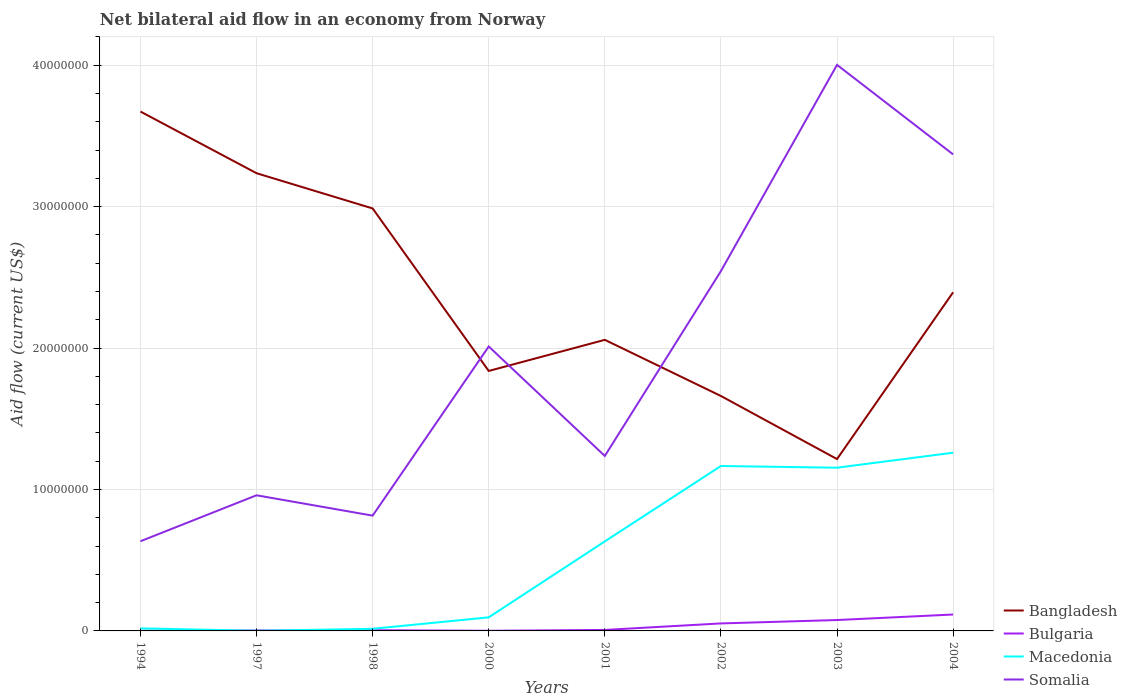Does the line corresponding to Bulgaria intersect with the line corresponding to Macedonia?
Ensure brevity in your answer.  Yes. Across all years, what is the maximum net bilateral aid flow in Bangladesh?
Offer a very short reply. 1.22e+07. What is the total net bilateral aid flow in Bangladesh in the graph?
Keep it short and to the point. 1.33e+07. What is the difference between the highest and the second highest net bilateral aid flow in Macedonia?
Provide a short and direct response. 1.26e+07. What is the difference between the highest and the lowest net bilateral aid flow in Somalia?
Your answer should be very brief. 4. Is the net bilateral aid flow in Bangladesh strictly greater than the net bilateral aid flow in Bulgaria over the years?
Your answer should be very brief. No. How many lines are there?
Offer a very short reply. 4. How many years are there in the graph?
Provide a short and direct response. 8. What is the difference between two consecutive major ticks on the Y-axis?
Provide a succinct answer. 1.00e+07. Where does the legend appear in the graph?
Provide a succinct answer. Bottom right. What is the title of the graph?
Provide a succinct answer. Net bilateral aid flow in an economy from Norway. What is the Aid flow (current US$) of Bangladesh in 1994?
Keep it short and to the point. 3.67e+07. What is the Aid flow (current US$) of Bulgaria in 1994?
Offer a very short reply. 10000. What is the Aid flow (current US$) in Somalia in 1994?
Make the answer very short. 6.34e+06. What is the Aid flow (current US$) in Bangladesh in 1997?
Your answer should be compact. 3.24e+07. What is the Aid flow (current US$) in Bulgaria in 1997?
Your answer should be compact. 3.00e+04. What is the Aid flow (current US$) in Macedonia in 1997?
Offer a terse response. 10000. What is the Aid flow (current US$) in Somalia in 1997?
Provide a short and direct response. 9.59e+06. What is the Aid flow (current US$) of Bangladesh in 1998?
Make the answer very short. 2.99e+07. What is the Aid flow (current US$) in Macedonia in 1998?
Give a very brief answer. 1.50e+05. What is the Aid flow (current US$) in Somalia in 1998?
Provide a short and direct response. 8.15e+06. What is the Aid flow (current US$) of Bangladesh in 2000?
Offer a terse response. 1.84e+07. What is the Aid flow (current US$) in Macedonia in 2000?
Ensure brevity in your answer.  9.60e+05. What is the Aid flow (current US$) of Somalia in 2000?
Your answer should be very brief. 2.01e+07. What is the Aid flow (current US$) in Bangladesh in 2001?
Your response must be concise. 2.06e+07. What is the Aid flow (current US$) of Macedonia in 2001?
Keep it short and to the point. 6.33e+06. What is the Aid flow (current US$) of Somalia in 2001?
Your response must be concise. 1.24e+07. What is the Aid flow (current US$) in Bangladesh in 2002?
Offer a very short reply. 1.66e+07. What is the Aid flow (current US$) of Bulgaria in 2002?
Keep it short and to the point. 5.30e+05. What is the Aid flow (current US$) in Macedonia in 2002?
Provide a succinct answer. 1.17e+07. What is the Aid flow (current US$) in Somalia in 2002?
Your answer should be compact. 2.54e+07. What is the Aid flow (current US$) of Bangladesh in 2003?
Ensure brevity in your answer.  1.22e+07. What is the Aid flow (current US$) in Bulgaria in 2003?
Provide a short and direct response. 7.70e+05. What is the Aid flow (current US$) of Macedonia in 2003?
Offer a very short reply. 1.15e+07. What is the Aid flow (current US$) in Somalia in 2003?
Give a very brief answer. 4.00e+07. What is the Aid flow (current US$) of Bangladesh in 2004?
Your answer should be very brief. 2.39e+07. What is the Aid flow (current US$) in Bulgaria in 2004?
Provide a succinct answer. 1.16e+06. What is the Aid flow (current US$) of Macedonia in 2004?
Your answer should be very brief. 1.26e+07. What is the Aid flow (current US$) in Somalia in 2004?
Provide a succinct answer. 3.37e+07. Across all years, what is the maximum Aid flow (current US$) of Bangladesh?
Give a very brief answer. 3.67e+07. Across all years, what is the maximum Aid flow (current US$) of Bulgaria?
Provide a succinct answer. 1.16e+06. Across all years, what is the maximum Aid flow (current US$) in Macedonia?
Keep it short and to the point. 1.26e+07. Across all years, what is the maximum Aid flow (current US$) in Somalia?
Provide a short and direct response. 4.00e+07. Across all years, what is the minimum Aid flow (current US$) of Bangladesh?
Your answer should be compact. 1.22e+07. Across all years, what is the minimum Aid flow (current US$) in Bulgaria?
Your response must be concise. 10000. Across all years, what is the minimum Aid flow (current US$) in Macedonia?
Provide a short and direct response. 10000. Across all years, what is the minimum Aid flow (current US$) of Somalia?
Keep it short and to the point. 6.34e+06. What is the total Aid flow (current US$) of Bangladesh in the graph?
Give a very brief answer. 1.91e+08. What is the total Aid flow (current US$) in Bulgaria in the graph?
Ensure brevity in your answer.  2.63e+06. What is the total Aid flow (current US$) of Macedonia in the graph?
Offer a terse response. 4.34e+07. What is the total Aid flow (current US$) in Somalia in the graph?
Provide a succinct answer. 1.56e+08. What is the difference between the Aid flow (current US$) in Bangladesh in 1994 and that in 1997?
Provide a succinct answer. 4.36e+06. What is the difference between the Aid flow (current US$) in Macedonia in 1994 and that in 1997?
Make the answer very short. 1.70e+05. What is the difference between the Aid flow (current US$) of Somalia in 1994 and that in 1997?
Ensure brevity in your answer.  -3.25e+06. What is the difference between the Aid flow (current US$) in Bangladesh in 1994 and that in 1998?
Make the answer very short. 6.85e+06. What is the difference between the Aid flow (current US$) of Macedonia in 1994 and that in 1998?
Offer a terse response. 3.00e+04. What is the difference between the Aid flow (current US$) in Somalia in 1994 and that in 1998?
Your response must be concise. -1.81e+06. What is the difference between the Aid flow (current US$) of Bangladesh in 1994 and that in 2000?
Ensure brevity in your answer.  1.83e+07. What is the difference between the Aid flow (current US$) of Macedonia in 1994 and that in 2000?
Give a very brief answer. -7.80e+05. What is the difference between the Aid flow (current US$) in Somalia in 1994 and that in 2000?
Your answer should be compact. -1.38e+07. What is the difference between the Aid flow (current US$) of Bangladesh in 1994 and that in 2001?
Give a very brief answer. 1.61e+07. What is the difference between the Aid flow (current US$) in Macedonia in 1994 and that in 2001?
Give a very brief answer. -6.15e+06. What is the difference between the Aid flow (current US$) of Somalia in 1994 and that in 2001?
Your response must be concise. -6.03e+06. What is the difference between the Aid flow (current US$) of Bangladesh in 1994 and that in 2002?
Keep it short and to the point. 2.01e+07. What is the difference between the Aid flow (current US$) of Bulgaria in 1994 and that in 2002?
Your response must be concise. -5.20e+05. What is the difference between the Aid flow (current US$) in Macedonia in 1994 and that in 2002?
Ensure brevity in your answer.  -1.15e+07. What is the difference between the Aid flow (current US$) of Somalia in 1994 and that in 2002?
Your response must be concise. -1.91e+07. What is the difference between the Aid flow (current US$) of Bangladesh in 1994 and that in 2003?
Your answer should be compact. 2.46e+07. What is the difference between the Aid flow (current US$) of Bulgaria in 1994 and that in 2003?
Give a very brief answer. -7.60e+05. What is the difference between the Aid flow (current US$) of Macedonia in 1994 and that in 2003?
Your answer should be very brief. -1.14e+07. What is the difference between the Aid flow (current US$) of Somalia in 1994 and that in 2003?
Provide a short and direct response. -3.37e+07. What is the difference between the Aid flow (current US$) in Bangladesh in 1994 and that in 2004?
Keep it short and to the point. 1.28e+07. What is the difference between the Aid flow (current US$) in Bulgaria in 1994 and that in 2004?
Offer a terse response. -1.15e+06. What is the difference between the Aid flow (current US$) in Macedonia in 1994 and that in 2004?
Ensure brevity in your answer.  -1.24e+07. What is the difference between the Aid flow (current US$) of Somalia in 1994 and that in 2004?
Your answer should be very brief. -2.74e+07. What is the difference between the Aid flow (current US$) in Bangladesh in 1997 and that in 1998?
Provide a short and direct response. 2.49e+06. What is the difference between the Aid flow (current US$) of Somalia in 1997 and that in 1998?
Your answer should be very brief. 1.44e+06. What is the difference between the Aid flow (current US$) in Bangladesh in 1997 and that in 2000?
Give a very brief answer. 1.40e+07. What is the difference between the Aid flow (current US$) of Bulgaria in 1997 and that in 2000?
Provide a succinct answer. 2.00e+04. What is the difference between the Aid flow (current US$) of Macedonia in 1997 and that in 2000?
Provide a succinct answer. -9.50e+05. What is the difference between the Aid flow (current US$) in Somalia in 1997 and that in 2000?
Give a very brief answer. -1.05e+07. What is the difference between the Aid flow (current US$) in Bangladesh in 1997 and that in 2001?
Keep it short and to the point. 1.18e+07. What is the difference between the Aid flow (current US$) of Macedonia in 1997 and that in 2001?
Make the answer very short. -6.32e+06. What is the difference between the Aid flow (current US$) in Somalia in 1997 and that in 2001?
Provide a short and direct response. -2.78e+06. What is the difference between the Aid flow (current US$) of Bangladesh in 1997 and that in 2002?
Provide a succinct answer. 1.58e+07. What is the difference between the Aid flow (current US$) of Bulgaria in 1997 and that in 2002?
Your answer should be compact. -5.00e+05. What is the difference between the Aid flow (current US$) in Macedonia in 1997 and that in 2002?
Offer a very short reply. -1.16e+07. What is the difference between the Aid flow (current US$) of Somalia in 1997 and that in 2002?
Give a very brief answer. -1.58e+07. What is the difference between the Aid flow (current US$) in Bangladesh in 1997 and that in 2003?
Offer a very short reply. 2.02e+07. What is the difference between the Aid flow (current US$) of Bulgaria in 1997 and that in 2003?
Offer a terse response. -7.40e+05. What is the difference between the Aid flow (current US$) of Macedonia in 1997 and that in 2003?
Make the answer very short. -1.15e+07. What is the difference between the Aid flow (current US$) in Somalia in 1997 and that in 2003?
Your answer should be very brief. -3.04e+07. What is the difference between the Aid flow (current US$) in Bangladesh in 1997 and that in 2004?
Offer a very short reply. 8.42e+06. What is the difference between the Aid flow (current US$) of Bulgaria in 1997 and that in 2004?
Your response must be concise. -1.13e+06. What is the difference between the Aid flow (current US$) of Macedonia in 1997 and that in 2004?
Offer a very short reply. -1.26e+07. What is the difference between the Aid flow (current US$) in Somalia in 1997 and that in 2004?
Make the answer very short. -2.41e+07. What is the difference between the Aid flow (current US$) in Bangladesh in 1998 and that in 2000?
Your response must be concise. 1.15e+07. What is the difference between the Aid flow (current US$) in Bulgaria in 1998 and that in 2000?
Your answer should be very brief. 4.00e+04. What is the difference between the Aid flow (current US$) in Macedonia in 1998 and that in 2000?
Ensure brevity in your answer.  -8.10e+05. What is the difference between the Aid flow (current US$) of Somalia in 1998 and that in 2000?
Provide a succinct answer. -1.20e+07. What is the difference between the Aid flow (current US$) in Bangladesh in 1998 and that in 2001?
Offer a terse response. 9.29e+06. What is the difference between the Aid flow (current US$) of Macedonia in 1998 and that in 2001?
Provide a succinct answer. -6.18e+06. What is the difference between the Aid flow (current US$) in Somalia in 1998 and that in 2001?
Give a very brief answer. -4.22e+06. What is the difference between the Aid flow (current US$) of Bangladesh in 1998 and that in 2002?
Your answer should be very brief. 1.33e+07. What is the difference between the Aid flow (current US$) of Bulgaria in 1998 and that in 2002?
Your answer should be compact. -4.80e+05. What is the difference between the Aid flow (current US$) in Macedonia in 1998 and that in 2002?
Make the answer very short. -1.15e+07. What is the difference between the Aid flow (current US$) of Somalia in 1998 and that in 2002?
Offer a very short reply. -1.73e+07. What is the difference between the Aid flow (current US$) of Bangladesh in 1998 and that in 2003?
Provide a short and direct response. 1.77e+07. What is the difference between the Aid flow (current US$) of Bulgaria in 1998 and that in 2003?
Ensure brevity in your answer.  -7.20e+05. What is the difference between the Aid flow (current US$) of Macedonia in 1998 and that in 2003?
Keep it short and to the point. -1.14e+07. What is the difference between the Aid flow (current US$) in Somalia in 1998 and that in 2003?
Offer a terse response. -3.19e+07. What is the difference between the Aid flow (current US$) of Bangladesh in 1998 and that in 2004?
Offer a very short reply. 5.93e+06. What is the difference between the Aid flow (current US$) in Bulgaria in 1998 and that in 2004?
Your answer should be very brief. -1.11e+06. What is the difference between the Aid flow (current US$) in Macedonia in 1998 and that in 2004?
Keep it short and to the point. -1.24e+07. What is the difference between the Aid flow (current US$) of Somalia in 1998 and that in 2004?
Make the answer very short. -2.55e+07. What is the difference between the Aid flow (current US$) in Bangladesh in 2000 and that in 2001?
Your answer should be very brief. -2.20e+06. What is the difference between the Aid flow (current US$) in Macedonia in 2000 and that in 2001?
Keep it short and to the point. -5.37e+06. What is the difference between the Aid flow (current US$) of Somalia in 2000 and that in 2001?
Keep it short and to the point. 7.74e+06. What is the difference between the Aid flow (current US$) in Bangladesh in 2000 and that in 2002?
Ensure brevity in your answer.  1.77e+06. What is the difference between the Aid flow (current US$) in Bulgaria in 2000 and that in 2002?
Provide a succinct answer. -5.20e+05. What is the difference between the Aid flow (current US$) of Macedonia in 2000 and that in 2002?
Ensure brevity in your answer.  -1.07e+07. What is the difference between the Aid flow (current US$) in Somalia in 2000 and that in 2002?
Ensure brevity in your answer.  -5.33e+06. What is the difference between the Aid flow (current US$) in Bangladesh in 2000 and that in 2003?
Offer a terse response. 6.23e+06. What is the difference between the Aid flow (current US$) of Bulgaria in 2000 and that in 2003?
Your response must be concise. -7.60e+05. What is the difference between the Aid flow (current US$) in Macedonia in 2000 and that in 2003?
Your answer should be very brief. -1.06e+07. What is the difference between the Aid flow (current US$) in Somalia in 2000 and that in 2003?
Your answer should be very brief. -1.99e+07. What is the difference between the Aid flow (current US$) in Bangladesh in 2000 and that in 2004?
Offer a terse response. -5.56e+06. What is the difference between the Aid flow (current US$) in Bulgaria in 2000 and that in 2004?
Make the answer very short. -1.15e+06. What is the difference between the Aid flow (current US$) in Macedonia in 2000 and that in 2004?
Offer a terse response. -1.16e+07. What is the difference between the Aid flow (current US$) of Somalia in 2000 and that in 2004?
Offer a terse response. -1.36e+07. What is the difference between the Aid flow (current US$) of Bangladesh in 2001 and that in 2002?
Offer a very short reply. 3.97e+06. What is the difference between the Aid flow (current US$) in Bulgaria in 2001 and that in 2002?
Your answer should be compact. -4.60e+05. What is the difference between the Aid flow (current US$) in Macedonia in 2001 and that in 2002?
Your response must be concise. -5.33e+06. What is the difference between the Aid flow (current US$) of Somalia in 2001 and that in 2002?
Make the answer very short. -1.31e+07. What is the difference between the Aid flow (current US$) in Bangladesh in 2001 and that in 2003?
Offer a terse response. 8.43e+06. What is the difference between the Aid flow (current US$) of Bulgaria in 2001 and that in 2003?
Offer a very short reply. -7.00e+05. What is the difference between the Aid flow (current US$) in Macedonia in 2001 and that in 2003?
Keep it short and to the point. -5.21e+06. What is the difference between the Aid flow (current US$) in Somalia in 2001 and that in 2003?
Give a very brief answer. -2.76e+07. What is the difference between the Aid flow (current US$) in Bangladesh in 2001 and that in 2004?
Offer a terse response. -3.36e+06. What is the difference between the Aid flow (current US$) in Bulgaria in 2001 and that in 2004?
Provide a short and direct response. -1.09e+06. What is the difference between the Aid flow (current US$) of Macedonia in 2001 and that in 2004?
Provide a succinct answer. -6.27e+06. What is the difference between the Aid flow (current US$) of Somalia in 2001 and that in 2004?
Keep it short and to the point. -2.13e+07. What is the difference between the Aid flow (current US$) of Bangladesh in 2002 and that in 2003?
Offer a terse response. 4.46e+06. What is the difference between the Aid flow (current US$) of Bulgaria in 2002 and that in 2003?
Give a very brief answer. -2.40e+05. What is the difference between the Aid flow (current US$) in Macedonia in 2002 and that in 2003?
Offer a terse response. 1.20e+05. What is the difference between the Aid flow (current US$) of Somalia in 2002 and that in 2003?
Provide a short and direct response. -1.46e+07. What is the difference between the Aid flow (current US$) in Bangladesh in 2002 and that in 2004?
Offer a very short reply. -7.33e+06. What is the difference between the Aid flow (current US$) in Bulgaria in 2002 and that in 2004?
Your answer should be compact. -6.30e+05. What is the difference between the Aid flow (current US$) of Macedonia in 2002 and that in 2004?
Give a very brief answer. -9.40e+05. What is the difference between the Aid flow (current US$) in Somalia in 2002 and that in 2004?
Keep it short and to the point. -8.25e+06. What is the difference between the Aid flow (current US$) of Bangladesh in 2003 and that in 2004?
Keep it short and to the point. -1.18e+07. What is the difference between the Aid flow (current US$) of Bulgaria in 2003 and that in 2004?
Provide a short and direct response. -3.90e+05. What is the difference between the Aid flow (current US$) in Macedonia in 2003 and that in 2004?
Provide a short and direct response. -1.06e+06. What is the difference between the Aid flow (current US$) of Somalia in 2003 and that in 2004?
Provide a short and direct response. 6.33e+06. What is the difference between the Aid flow (current US$) of Bangladesh in 1994 and the Aid flow (current US$) of Bulgaria in 1997?
Your response must be concise. 3.67e+07. What is the difference between the Aid flow (current US$) in Bangladesh in 1994 and the Aid flow (current US$) in Macedonia in 1997?
Give a very brief answer. 3.67e+07. What is the difference between the Aid flow (current US$) of Bangladesh in 1994 and the Aid flow (current US$) of Somalia in 1997?
Make the answer very short. 2.71e+07. What is the difference between the Aid flow (current US$) of Bulgaria in 1994 and the Aid flow (current US$) of Macedonia in 1997?
Provide a succinct answer. 0. What is the difference between the Aid flow (current US$) in Bulgaria in 1994 and the Aid flow (current US$) in Somalia in 1997?
Ensure brevity in your answer.  -9.58e+06. What is the difference between the Aid flow (current US$) in Macedonia in 1994 and the Aid flow (current US$) in Somalia in 1997?
Offer a very short reply. -9.41e+06. What is the difference between the Aid flow (current US$) in Bangladesh in 1994 and the Aid flow (current US$) in Bulgaria in 1998?
Your answer should be compact. 3.67e+07. What is the difference between the Aid flow (current US$) in Bangladesh in 1994 and the Aid flow (current US$) in Macedonia in 1998?
Your answer should be very brief. 3.66e+07. What is the difference between the Aid flow (current US$) in Bangladesh in 1994 and the Aid flow (current US$) in Somalia in 1998?
Keep it short and to the point. 2.86e+07. What is the difference between the Aid flow (current US$) in Bulgaria in 1994 and the Aid flow (current US$) in Macedonia in 1998?
Your answer should be compact. -1.40e+05. What is the difference between the Aid flow (current US$) in Bulgaria in 1994 and the Aid flow (current US$) in Somalia in 1998?
Provide a short and direct response. -8.14e+06. What is the difference between the Aid flow (current US$) in Macedonia in 1994 and the Aid flow (current US$) in Somalia in 1998?
Ensure brevity in your answer.  -7.97e+06. What is the difference between the Aid flow (current US$) of Bangladesh in 1994 and the Aid flow (current US$) of Bulgaria in 2000?
Ensure brevity in your answer.  3.67e+07. What is the difference between the Aid flow (current US$) of Bangladesh in 1994 and the Aid flow (current US$) of Macedonia in 2000?
Offer a very short reply. 3.58e+07. What is the difference between the Aid flow (current US$) of Bangladesh in 1994 and the Aid flow (current US$) of Somalia in 2000?
Ensure brevity in your answer.  1.66e+07. What is the difference between the Aid flow (current US$) in Bulgaria in 1994 and the Aid flow (current US$) in Macedonia in 2000?
Provide a succinct answer. -9.50e+05. What is the difference between the Aid flow (current US$) in Bulgaria in 1994 and the Aid flow (current US$) in Somalia in 2000?
Offer a very short reply. -2.01e+07. What is the difference between the Aid flow (current US$) of Macedonia in 1994 and the Aid flow (current US$) of Somalia in 2000?
Provide a succinct answer. -1.99e+07. What is the difference between the Aid flow (current US$) in Bangladesh in 1994 and the Aid flow (current US$) in Bulgaria in 2001?
Your answer should be very brief. 3.66e+07. What is the difference between the Aid flow (current US$) of Bangladesh in 1994 and the Aid flow (current US$) of Macedonia in 2001?
Your response must be concise. 3.04e+07. What is the difference between the Aid flow (current US$) of Bangladesh in 1994 and the Aid flow (current US$) of Somalia in 2001?
Ensure brevity in your answer.  2.44e+07. What is the difference between the Aid flow (current US$) of Bulgaria in 1994 and the Aid flow (current US$) of Macedonia in 2001?
Provide a short and direct response. -6.32e+06. What is the difference between the Aid flow (current US$) in Bulgaria in 1994 and the Aid flow (current US$) in Somalia in 2001?
Provide a short and direct response. -1.24e+07. What is the difference between the Aid flow (current US$) in Macedonia in 1994 and the Aid flow (current US$) in Somalia in 2001?
Provide a short and direct response. -1.22e+07. What is the difference between the Aid flow (current US$) of Bangladesh in 1994 and the Aid flow (current US$) of Bulgaria in 2002?
Give a very brief answer. 3.62e+07. What is the difference between the Aid flow (current US$) in Bangladesh in 1994 and the Aid flow (current US$) in Macedonia in 2002?
Ensure brevity in your answer.  2.51e+07. What is the difference between the Aid flow (current US$) in Bangladesh in 1994 and the Aid flow (current US$) in Somalia in 2002?
Your answer should be compact. 1.13e+07. What is the difference between the Aid flow (current US$) of Bulgaria in 1994 and the Aid flow (current US$) of Macedonia in 2002?
Provide a succinct answer. -1.16e+07. What is the difference between the Aid flow (current US$) of Bulgaria in 1994 and the Aid flow (current US$) of Somalia in 2002?
Give a very brief answer. -2.54e+07. What is the difference between the Aid flow (current US$) of Macedonia in 1994 and the Aid flow (current US$) of Somalia in 2002?
Offer a very short reply. -2.53e+07. What is the difference between the Aid flow (current US$) in Bangladesh in 1994 and the Aid flow (current US$) in Bulgaria in 2003?
Your answer should be very brief. 3.60e+07. What is the difference between the Aid flow (current US$) in Bangladesh in 1994 and the Aid flow (current US$) in Macedonia in 2003?
Make the answer very short. 2.52e+07. What is the difference between the Aid flow (current US$) of Bangladesh in 1994 and the Aid flow (current US$) of Somalia in 2003?
Your response must be concise. -3.30e+06. What is the difference between the Aid flow (current US$) in Bulgaria in 1994 and the Aid flow (current US$) in Macedonia in 2003?
Give a very brief answer. -1.15e+07. What is the difference between the Aid flow (current US$) of Bulgaria in 1994 and the Aid flow (current US$) of Somalia in 2003?
Ensure brevity in your answer.  -4.00e+07. What is the difference between the Aid flow (current US$) in Macedonia in 1994 and the Aid flow (current US$) in Somalia in 2003?
Your answer should be very brief. -3.98e+07. What is the difference between the Aid flow (current US$) in Bangladesh in 1994 and the Aid flow (current US$) in Bulgaria in 2004?
Offer a very short reply. 3.56e+07. What is the difference between the Aid flow (current US$) in Bangladesh in 1994 and the Aid flow (current US$) in Macedonia in 2004?
Offer a very short reply. 2.41e+07. What is the difference between the Aid flow (current US$) of Bangladesh in 1994 and the Aid flow (current US$) of Somalia in 2004?
Your answer should be very brief. 3.03e+06. What is the difference between the Aid flow (current US$) of Bulgaria in 1994 and the Aid flow (current US$) of Macedonia in 2004?
Provide a short and direct response. -1.26e+07. What is the difference between the Aid flow (current US$) in Bulgaria in 1994 and the Aid flow (current US$) in Somalia in 2004?
Make the answer very short. -3.37e+07. What is the difference between the Aid flow (current US$) in Macedonia in 1994 and the Aid flow (current US$) in Somalia in 2004?
Your response must be concise. -3.35e+07. What is the difference between the Aid flow (current US$) in Bangladesh in 1997 and the Aid flow (current US$) in Bulgaria in 1998?
Your response must be concise. 3.23e+07. What is the difference between the Aid flow (current US$) in Bangladesh in 1997 and the Aid flow (current US$) in Macedonia in 1998?
Make the answer very short. 3.22e+07. What is the difference between the Aid flow (current US$) in Bangladesh in 1997 and the Aid flow (current US$) in Somalia in 1998?
Give a very brief answer. 2.42e+07. What is the difference between the Aid flow (current US$) in Bulgaria in 1997 and the Aid flow (current US$) in Somalia in 1998?
Keep it short and to the point. -8.12e+06. What is the difference between the Aid flow (current US$) of Macedonia in 1997 and the Aid flow (current US$) of Somalia in 1998?
Keep it short and to the point. -8.14e+06. What is the difference between the Aid flow (current US$) in Bangladesh in 1997 and the Aid flow (current US$) in Bulgaria in 2000?
Your answer should be compact. 3.24e+07. What is the difference between the Aid flow (current US$) in Bangladesh in 1997 and the Aid flow (current US$) in Macedonia in 2000?
Provide a short and direct response. 3.14e+07. What is the difference between the Aid flow (current US$) in Bangladesh in 1997 and the Aid flow (current US$) in Somalia in 2000?
Make the answer very short. 1.22e+07. What is the difference between the Aid flow (current US$) in Bulgaria in 1997 and the Aid flow (current US$) in Macedonia in 2000?
Your answer should be compact. -9.30e+05. What is the difference between the Aid flow (current US$) in Bulgaria in 1997 and the Aid flow (current US$) in Somalia in 2000?
Your response must be concise. -2.01e+07. What is the difference between the Aid flow (current US$) of Macedonia in 1997 and the Aid flow (current US$) of Somalia in 2000?
Keep it short and to the point. -2.01e+07. What is the difference between the Aid flow (current US$) of Bangladesh in 1997 and the Aid flow (current US$) of Bulgaria in 2001?
Your answer should be compact. 3.23e+07. What is the difference between the Aid flow (current US$) in Bangladesh in 1997 and the Aid flow (current US$) in Macedonia in 2001?
Provide a short and direct response. 2.60e+07. What is the difference between the Aid flow (current US$) in Bangladesh in 1997 and the Aid flow (current US$) in Somalia in 2001?
Offer a very short reply. 2.00e+07. What is the difference between the Aid flow (current US$) in Bulgaria in 1997 and the Aid flow (current US$) in Macedonia in 2001?
Keep it short and to the point. -6.30e+06. What is the difference between the Aid flow (current US$) in Bulgaria in 1997 and the Aid flow (current US$) in Somalia in 2001?
Your answer should be compact. -1.23e+07. What is the difference between the Aid flow (current US$) in Macedonia in 1997 and the Aid flow (current US$) in Somalia in 2001?
Keep it short and to the point. -1.24e+07. What is the difference between the Aid flow (current US$) in Bangladesh in 1997 and the Aid flow (current US$) in Bulgaria in 2002?
Provide a succinct answer. 3.18e+07. What is the difference between the Aid flow (current US$) of Bangladesh in 1997 and the Aid flow (current US$) of Macedonia in 2002?
Keep it short and to the point. 2.07e+07. What is the difference between the Aid flow (current US$) of Bangladesh in 1997 and the Aid flow (current US$) of Somalia in 2002?
Your answer should be very brief. 6.92e+06. What is the difference between the Aid flow (current US$) in Bulgaria in 1997 and the Aid flow (current US$) in Macedonia in 2002?
Make the answer very short. -1.16e+07. What is the difference between the Aid flow (current US$) in Bulgaria in 1997 and the Aid flow (current US$) in Somalia in 2002?
Provide a short and direct response. -2.54e+07. What is the difference between the Aid flow (current US$) of Macedonia in 1997 and the Aid flow (current US$) of Somalia in 2002?
Provide a short and direct response. -2.54e+07. What is the difference between the Aid flow (current US$) of Bangladesh in 1997 and the Aid flow (current US$) of Bulgaria in 2003?
Provide a succinct answer. 3.16e+07. What is the difference between the Aid flow (current US$) of Bangladesh in 1997 and the Aid flow (current US$) of Macedonia in 2003?
Your answer should be very brief. 2.08e+07. What is the difference between the Aid flow (current US$) in Bangladesh in 1997 and the Aid flow (current US$) in Somalia in 2003?
Provide a short and direct response. -7.66e+06. What is the difference between the Aid flow (current US$) of Bulgaria in 1997 and the Aid flow (current US$) of Macedonia in 2003?
Your answer should be compact. -1.15e+07. What is the difference between the Aid flow (current US$) in Bulgaria in 1997 and the Aid flow (current US$) in Somalia in 2003?
Keep it short and to the point. -4.00e+07. What is the difference between the Aid flow (current US$) in Macedonia in 1997 and the Aid flow (current US$) in Somalia in 2003?
Provide a short and direct response. -4.00e+07. What is the difference between the Aid flow (current US$) in Bangladesh in 1997 and the Aid flow (current US$) in Bulgaria in 2004?
Offer a terse response. 3.12e+07. What is the difference between the Aid flow (current US$) of Bangladesh in 1997 and the Aid flow (current US$) of Macedonia in 2004?
Keep it short and to the point. 1.98e+07. What is the difference between the Aid flow (current US$) in Bangladesh in 1997 and the Aid flow (current US$) in Somalia in 2004?
Your response must be concise. -1.33e+06. What is the difference between the Aid flow (current US$) in Bulgaria in 1997 and the Aid flow (current US$) in Macedonia in 2004?
Ensure brevity in your answer.  -1.26e+07. What is the difference between the Aid flow (current US$) of Bulgaria in 1997 and the Aid flow (current US$) of Somalia in 2004?
Keep it short and to the point. -3.37e+07. What is the difference between the Aid flow (current US$) in Macedonia in 1997 and the Aid flow (current US$) in Somalia in 2004?
Provide a succinct answer. -3.37e+07. What is the difference between the Aid flow (current US$) in Bangladesh in 1998 and the Aid flow (current US$) in Bulgaria in 2000?
Make the answer very short. 2.99e+07. What is the difference between the Aid flow (current US$) in Bangladesh in 1998 and the Aid flow (current US$) in Macedonia in 2000?
Keep it short and to the point. 2.89e+07. What is the difference between the Aid flow (current US$) in Bangladesh in 1998 and the Aid flow (current US$) in Somalia in 2000?
Keep it short and to the point. 9.76e+06. What is the difference between the Aid flow (current US$) in Bulgaria in 1998 and the Aid flow (current US$) in Macedonia in 2000?
Make the answer very short. -9.10e+05. What is the difference between the Aid flow (current US$) of Bulgaria in 1998 and the Aid flow (current US$) of Somalia in 2000?
Your answer should be very brief. -2.01e+07. What is the difference between the Aid flow (current US$) in Macedonia in 1998 and the Aid flow (current US$) in Somalia in 2000?
Offer a terse response. -2.00e+07. What is the difference between the Aid flow (current US$) of Bangladesh in 1998 and the Aid flow (current US$) of Bulgaria in 2001?
Make the answer very short. 2.98e+07. What is the difference between the Aid flow (current US$) in Bangladesh in 1998 and the Aid flow (current US$) in Macedonia in 2001?
Your answer should be compact. 2.35e+07. What is the difference between the Aid flow (current US$) of Bangladesh in 1998 and the Aid flow (current US$) of Somalia in 2001?
Your answer should be compact. 1.75e+07. What is the difference between the Aid flow (current US$) of Bulgaria in 1998 and the Aid flow (current US$) of Macedonia in 2001?
Ensure brevity in your answer.  -6.28e+06. What is the difference between the Aid flow (current US$) of Bulgaria in 1998 and the Aid flow (current US$) of Somalia in 2001?
Offer a terse response. -1.23e+07. What is the difference between the Aid flow (current US$) of Macedonia in 1998 and the Aid flow (current US$) of Somalia in 2001?
Provide a succinct answer. -1.22e+07. What is the difference between the Aid flow (current US$) of Bangladesh in 1998 and the Aid flow (current US$) of Bulgaria in 2002?
Provide a succinct answer. 2.93e+07. What is the difference between the Aid flow (current US$) of Bangladesh in 1998 and the Aid flow (current US$) of Macedonia in 2002?
Your response must be concise. 1.82e+07. What is the difference between the Aid flow (current US$) in Bangladesh in 1998 and the Aid flow (current US$) in Somalia in 2002?
Your answer should be compact. 4.43e+06. What is the difference between the Aid flow (current US$) of Bulgaria in 1998 and the Aid flow (current US$) of Macedonia in 2002?
Your answer should be very brief. -1.16e+07. What is the difference between the Aid flow (current US$) in Bulgaria in 1998 and the Aid flow (current US$) in Somalia in 2002?
Provide a short and direct response. -2.54e+07. What is the difference between the Aid flow (current US$) of Macedonia in 1998 and the Aid flow (current US$) of Somalia in 2002?
Offer a terse response. -2.53e+07. What is the difference between the Aid flow (current US$) of Bangladesh in 1998 and the Aid flow (current US$) of Bulgaria in 2003?
Offer a terse response. 2.91e+07. What is the difference between the Aid flow (current US$) of Bangladesh in 1998 and the Aid flow (current US$) of Macedonia in 2003?
Keep it short and to the point. 1.83e+07. What is the difference between the Aid flow (current US$) of Bangladesh in 1998 and the Aid flow (current US$) of Somalia in 2003?
Make the answer very short. -1.02e+07. What is the difference between the Aid flow (current US$) in Bulgaria in 1998 and the Aid flow (current US$) in Macedonia in 2003?
Your answer should be compact. -1.15e+07. What is the difference between the Aid flow (current US$) in Bulgaria in 1998 and the Aid flow (current US$) in Somalia in 2003?
Make the answer very short. -4.00e+07. What is the difference between the Aid flow (current US$) of Macedonia in 1998 and the Aid flow (current US$) of Somalia in 2003?
Make the answer very short. -3.99e+07. What is the difference between the Aid flow (current US$) of Bangladesh in 1998 and the Aid flow (current US$) of Bulgaria in 2004?
Offer a terse response. 2.87e+07. What is the difference between the Aid flow (current US$) of Bangladesh in 1998 and the Aid flow (current US$) of Macedonia in 2004?
Offer a terse response. 1.73e+07. What is the difference between the Aid flow (current US$) in Bangladesh in 1998 and the Aid flow (current US$) in Somalia in 2004?
Offer a very short reply. -3.82e+06. What is the difference between the Aid flow (current US$) in Bulgaria in 1998 and the Aid flow (current US$) in Macedonia in 2004?
Your answer should be compact. -1.26e+07. What is the difference between the Aid flow (current US$) in Bulgaria in 1998 and the Aid flow (current US$) in Somalia in 2004?
Provide a short and direct response. -3.36e+07. What is the difference between the Aid flow (current US$) of Macedonia in 1998 and the Aid flow (current US$) of Somalia in 2004?
Offer a terse response. -3.35e+07. What is the difference between the Aid flow (current US$) of Bangladesh in 2000 and the Aid flow (current US$) of Bulgaria in 2001?
Provide a short and direct response. 1.83e+07. What is the difference between the Aid flow (current US$) in Bangladesh in 2000 and the Aid flow (current US$) in Macedonia in 2001?
Offer a very short reply. 1.20e+07. What is the difference between the Aid flow (current US$) in Bangladesh in 2000 and the Aid flow (current US$) in Somalia in 2001?
Give a very brief answer. 6.01e+06. What is the difference between the Aid flow (current US$) of Bulgaria in 2000 and the Aid flow (current US$) of Macedonia in 2001?
Give a very brief answer. -6.32e+06. What is the difference between the Aid flow (current US$) in Bulgaria in 2000 and the Aid flow (current US$) in Somalia in 2001?
Your response must be concise. -1.24e+07. What is the difference between the Aid flow (current US$) in Macedonia in 2000 and the Aid flow (current US$) in Somalia in 2001?
Make the answer very short. -1.14e+07. What is the difference between the Aid flow (current US$) of Bangladesh in 2000 and the Aid flow (current US$) of Bulgaria in 2002?
Your answer should be very brief. 1.78e+07. What is the difference between the Aid flow (current US$) in Bangladesh in 2000 and the Aid flow (current US$) in Macedonia in 2002?
Make the answer very short. 6.72e+06. What is the difference between the Aid flow (current US$) of Bangladesh in 2000 and the Aid flow (current US$) of Somalia in 2002?
Your answer should be very brief. -7.06e+06. What is the difference between the Aid flow (current US$) of Bulgaria in 2000 and the Aid flow (current US$) of Macedonia in 2002?
Provide a short and direct response. -1.16e+07. What is the difference between the Aid flow (current US$) of Bulgaria in 2000 and the Aid flow (current US$) of Somalia in 2002?
Your answer should be compact. -2.54e+07. What is the difference between the Aid flow (current US$) of Macedonia in 2000 and the Aid flow (current US$) of Somalia in 2002?
Offer a terse response. -2.45e+07. What is the difference between the Aid flow (current US$) of Bangladesh in 2000 and the Aid flow (current US$) of Bulgaria in 2003?
Your response must be concise. 1.76e+07. What is the difference between the Aid flow (current US$) of Bangladesh in 2000 and the Aid flow (current US$) of Macedonia in 2003?
Ensure brevity in your answer.  6.84e+06. What is the difference between the Aid flow (current US$) in Bangladesh in 2000 and the Aid flow (current US$) in Somalia in 2003?
Offer a very short reply. -2.16e+07. What is the difference between the Aid flow (current US$) in Bulgaria in 2000 and the Aid flow (current US$) in Macedonia in 2003?
Give a very brief answer. -1.15e+07. What is the difference between the Aid flow (current US$) in Bulgaria in 2000 and the Aid flow (current US$) in Somalia in 2003?
Give a very brief answer. -4.00e+07. What is the difference between the Aid flow (current US$) in Macedonia in 2000 and the Aid flow (current US$) in Somalia in 2003?
Provide a short and direct response. -3.91e+07. What is the difference between the Aid flow (current US$) of Bangladesh in 2000 and the Aid flow (current US$) of Bulgaria in 2004?
Offer a terse response. 1.72e+07. What is the difference between the Aid flow (current US$) of Bangladesh in 2000 and the Aid flow (current US$) of Macedonia in 2004?
Your response must be concise. 5.78e+06. What is the difference between the Aid flow (current US$) in Bangladesh in 2000 and the Aid flow (current US$) in Somalia in 2004?
Provide a succinct answer. -1.53e+07. What is the difference between the Aid flow (current US$) in Bulgaria in 2000 and the Aid flow (current US$) in Macedonia in 2004?
Keep it short and to the point. -1.26e+07. What is the difference between the Aid flow (current US$) in Bulgaria in 2000 and the Aid flow (current US$) in Somalia in 2004?
Provide a succinct answer. -3.37e+07. What is the difference between the Aid flow (current US$) in Macedonia in 2000 and the Aid flow (current US$) in Somalia in 2004?
Make the answer very short. -3.27e+07. What is the difference between the Aid flow (current US$) of Bangladesh in 2001 and the Aid flow (current US$) of Bulgaria in 2002?
Ensure brevity in your answer.  2.00e+07. What is the difference between the Aid flow (current US$) of Bangladesh in 2001 and the Aid flow (current US$) of Macedonia in 2002?
Offer a very short reply. 8.92e+06. What is the difference between the Aid flow (current US$) of Bangladesh in 2001 and the Aid flow (current US$) of Somalia in 2002?
Offer a very short reply. -4.86e+06. What is the difference between the Aid flow (current US$) of Bulgaria in 2001 and the Aid flow (current US$) of Macedonia in 2002?
Your response must be concise. -1.16e+07. What is the difference between the Aid flow (current US$) in Bulgaria in 2001 and the Aid flow (current US$) in Somalia in 2002?
Provide a succinct answer. -2.54e+07. What is the difference between the Aid flow (current US$) of Macedonia in 2001 and the Aid flow (current US$) of Somalia in 2002?
Ensure brevity in your answer.  -1.91e+07. What is the difference between the Aid flow (current US$) of Bangladesh in 2001 and the Aid flow (current US$) of Bulgaria in 2003?
Make the answer very short. 1.98e+07. What is the difference between the Aid flow (current US$) of Bangladesh in 2001 and the Aid flow (current US$) of Macedonia in 2003?
Provide a short and direct response. 9.04e+06. What is the difference between the Aid flow (current US$) in Bangladesh in 2001 and the Aid flow (current US$) in Somalia in 2003?
Give a very brief answer. -1.94e+07. What is the difference between the Aid flow (current US$) of Bulgaria in 2001 and the Aid flow (current US$) of Macedonia in 2003?
Keep it short and to the point. -1.15e+07. What is the difference between the Aid flow (current US$) of Bulgaria in 2001 and the Aid flow (current US$) of Somalia in 2003?
Keep it short and to the point. -4.00e+07. What is the difference between the Aid flow (current US$) of Macedonia in 2001 and the Aid flow (current US$) of Somalia in 2003?
Provide a short and direct response. -3.37e+07. What is the difference between the Aid flow (current US$) of Bangladesh in 2001 and the Aid flow (current US$) of Bulgaria in 2004?
Provide a short and direct response. 1.94e+07. What is the difference between the Aid flow (current US$) in Bangladesh in 2001 and the Aid flow (current US$) in Macedonia in 2004?
Your response must be concise. 7.98e+06. What is the difference between the Aid flow (current US$) of Bangladesh in 2001 and the Aid flow (current US$) of Somalia in 2004?
Ensure brevity in your answer.  -1.31e+07. What is the difference between the Aid flow (current US$) in Bulgaria in 2001 and the Aid flow (current US$) in Macedonia in 2004?
Offer a very short reply. -1.25e+07. What is the difference between the Aid flow (current US$) of Bulgaria in 2001 and the Aid flow (current US$) of Somalia in 2004?
Your answer should be compact. -3.36e+07. What is the difference between the Aid flow (current US$) in Macedonia in 2001 and the Aid flow (current US$) in Somalia in 2004?
Make the answer very short. -2.74e+07. What is the difference between the Aid flow (current US$) in Bangladesh in 2002 and the Aid flow (current US$) in Bulgaria in 2003?
Your answer should be very brief. 1.58e+07. What is the difference between the Aid flow (current US$) of Bangladesh in 2002 and the Aid flow (current US$) of Macedonia in 2003?
Offer a very short reply. 5.07e+06. What is the difference between the Aid flow (current US$) in Bangladesh in 2002 and the Aid flow (current US$) in Somalia in 2003?
Provide a succinct answer. -2.34e+07. What is the difference between the Aid flow (current US$) of Bulgaria in 2002 and the Aid flow (current US$) of Macedonia in 2003?
Keep it short and to the point. -1.10e+07. What is the difference between the Aid flow (current US$) of Bulgaria in 2002 and the Aid flow (current US$) of Somalia in 2003?
Offer a terse response. -3.95e+07. What is the difference between the Aid flow (current US$) of Macedonia in 2002 and the Aid flow (current US$) of Somalia in 2003?
Keep it short and to the point. -2.84e+07. What is the difference between the Aid flow (current US$) in Bangladesh in 2002 and the Aid flow (current US$) in Bulgaria in 2004?
Your answer should be very brief. 1.54e+07. What is the difference between the Aid flow (current US$) in Bangladesh in 2002 and the Aid flow (current US$) in Macedonia in 2004?
Make the answer very short. 4.01e+06. What is the difference between the Aid flow (current US$) of Bangladesh in 2002 and the Aid flow (current US$) of Somalia in 2004?
Your response must be concise. -1.71e+07. What is the difference between the Aid flow (current US$) in Bulgaria in 2002 and the Aid flow (current US$) in Macedonia in 2004?
Give a very brief answer. -1.21e+07. What is the difference between the Aid flow (current US$) in Bulgaria in 2002 and the Aid flow (current US$) in Somalia in 2004?
Provide a succinct answer. -3.32e+07. What is the difference between the Aid flow (current US$) in Macedonia in 2002 and the Aid flow (current US$) in Somalia in 2004?
Your answer should be very brief. -2.20e+07. What is the difference between the Aid flow (current US$) in Bangladesh in 2003 and the Aid flow (current US$) in Bulgaria in 2004?
Make the answer very short. 1.10e+07. What is the difference between the Aid flow (current US$) of Bangladesh in 2003 and the Aid flow (current US$) of Macedonia in 2004?
Offer a very short reply. -4.50e+05. What is the difference between the Aid flow (current US$) in Bangladesh in 2003 and the Aid flow (current US$) in Somalia in 2004?
Make the answer very short. -2.15e+07. What is the difference between the Aid flow (current US$) of Bulgaria in 2003 and the Aid flow (current US$) of Macedonia in 2004?
Keep it short and to the point. -1.18e+07. What is the difference between the Aid flow (current US$) of Bulgaria in 2003 and the Aid flow (current US$) of Somalia in 2004?
Your response must be concise. -3.29e+07. What is the difference between the Aid flow (current US$) in Macedonia in 2003 and the Aid flow (current US$) in Somalia in 2004?
Provide a succinct answer. -2.22e+07. What is the average Aid flow (current US$) in Bangladesh per year?
Provide a succinct answer. 2.38e+07. What is the average Aid flow (current US$) of Bulgaria per year?
Ensure brevity in your answer.  3.29e+05. What is the average Aid flow (current US$) of Macedonia per year?
Ensure brevity in your answer.  5.43e+06. What is the average Aid flow (current US$) of Somalia per year?
Make the answer very short. 1.95e+07. In the year 1994, what is the difference between the Aid flow (current US$) in Bangladesh and Aid flow (current US$) in Bulgaria?
Offer a very short reply. 3.67e+07. In the year 1994, what is the difference between the Aid flow (current US$) in Bangladesh and Aid flow (current US$) in Macedonia?
Give a very brief answer. 3.65e+07. In the year 1994, what is the difference between the Aid flow (current US$) of Bangladesh and Aid flow (current US$) of Somalia?
Your answer should be compact. 3.04e+07. In the year 1994, what is the difference between the Aid flow (current US$) in Bulgaria and Aid flow (current US$) in Somalia?
Provide a succinct answer. -6.33e+06. In the year 1994, what is the difference between the Aid flow (current US$) in Macedonia and Aid flow (current US$) in Somalia?
Your response must be concise. -6.16e+06. In the year 1997, what is the difference between the Aid flow (current US$) of Bangladesh and Aid flow (current US$) of Bulgaria?
Ensure brevity in your answer.  3.23e+07. In the year 1997, what is the difference between the Aid flow (current US$) in Bangladesh and Aid flow (current US$) in Macedonia?
Keep it short and to the point. 3.24e+07. In the year 1997, what is the difference between the Aid flow (current US$) of Bangladesh and Aid flow (current US$) of Somalia?
Offer a terse response. 2.28e+07. In the year 1997, what is the difference between the Aid flow (current US$) of Bulgaria and Aid flow (current US$) of Somalia?
Give a very brief answer. -9.56e+06. In the year 1997, what is the difference between the Aid flow (current US$) in Macedonia and Aid flow (current US$) in Somalia?
Provide a succinct answer. -9.58e+06. In the year 1998, what is the difference between the Aid flow (current US$) of Bangladesh and Aid flow (current US$) of Bulgaria?
Your answer should be very brief. 2.98e+07. In the year 1998, what is the difference between the Aid flow (current US$) in Bangladesh and Aid flow (current US$) in Macedonia?
Ensure brevity in your answer.  2.97e+07. In the year 1998, what is the difference between the Aid flow (current US$) of Bangladesh and Aid flow (current US$) of Somalia?
Give a very brief answer. 2.17e+07. In the year 1998, what is the difference between the Aid flow (current US$) of Bulgaria and Aid flow (current US$) of Macedonia?
Provide a short and direct response. -1.00e+05. In the year 1998, what is the difference between the Aid flow (current US$) in Bulgaria and Aid flow (current US$) in Somalia?
Give a very brief answer. -8.10e+06. In the year 1998, what is the difference between the Aid flow (current US$) of Macedonia and Aid flow (current US$) of Somalia?
Give a very brief answer. -8.00e+06. In the year 2000, what is the difference between the Aid flow (current US$) of Bangladesh and Aid flow (current US$) of Bulgaria?
Offer a very short reply. 1.84e+07. In the year 2000, what is the difference between the Aid flow (current US$) of Bangladesh and Aid flow (current US$) of Macedonia?
Offer a very short reply. 1.74e+07. In the year 2000, what is the difference between the Aid flow (current US$) in Bangladesh and Aid flow (current US$) in Somalia?
Keep it short and to the point. -1.73e+06. In the year 2000, what is the difference between the Aid flow (current US$) in Bulgaria and Aid flow (current US$) in Macedonia?
Offer a very short reply. -9.50e+05. In the year 2000, what is the difference between the Aid flow (current US$) of Bulgaria and Aid flow (current US$) of Somalia?
Give a very brief answer. -2.01e+07. In the year 2000, what is the difference between the Aid flow (current US$) of Macedonia and Aid flow (current US$) of Somalia?
Keep it short and to the point. -1.92e+07. In the year 2001, what is the difference between the Aid flow (current US$) in Bangladesh and Aid flow (current US$) in Bulgaria?
Your answer should be compact. 2.05e+07. In the year 2001, what is the difference between the Aid flow (current US$) of Bangladesh and Aid flow (current US$) of Macedonia?
Provide a short and direct response. 1.42e+07. In the year 2001, what is the difference between the Aid flow (current US$) of Bangladesh and Aid flow (current US$) of Somalia?
Offer a terse response. 8.21e+06. In the year 2001, what is the difference between the Aid flow (current US$) of Bulgaria and Aid flow (current US$) of Macedonia?
Offer a very short reply. -6.26e+06. In the year 2001, what is the difference between the Aid flow (current US$) in Bulgaria and Aid flow (current US$) in Somalia?
Offer a terse response. -1.23e+07. In the year 2001, what is the difference between the Aid flow (current US$) of Macedonia and Aid flow (current US$) of Somalia?
Your answer should be compact. -6.04e+06. In the year 2002, what is the difference between the Aid flow (current US$) of Bangladesh and Aid flow (current US$) of Bulgaria?
Ensure brevity in your answer.  1.61e+07. In the year 2002, what is the difference between the Aid flow (current US$) of Bangladesh and Aid flow (current US$) of Macedonia?
Your answer should be compact. 4.95e+06. In the year 2002, what is the difference between the Aid flow (current US$) of Bangladesh and Aid flow (current US$) of Somalia?
Your response must be concise. -8.83e+06. In the year 2002, what is the difference between the Aid flow (current US$) of Bulgaria and Aid flow (current US$) of Macedonia?
Offer a terse response. -1.11e+07. In the year 2002, what is the difference between the Aid flow (current US$) of Bulgaria and Aid flow (current US$) of Somalia?
Your answer should be compact. -2.49e+07. In the year 2002, what is the difference between the Aid flow (current US$) of Macedonia and Aid flow (current US$) of Somalia?
Ensure brevity in your answer.  -1.38e+07. In the year 2003, what is the difference between the Aid flow (current US$) in Bangladesh and Aid flow (current US$) in Bulgaria?
Keep it short and to the point. 1.14e+07. In the year 2003, what is the difference between the Aid flow (current US$) in Bangladesh and Aid flow (current US$) in Macedonia?
Make the answer very short. 6.10e+05. In the year 2003, what is the difference between the Aid flow (current US$) of Bangladesh and Aid flow (current US$) of Somalia?
Your answer should be very brief. -2.79e+07. In the year 2003, what is the difference between the Aid flow (current US$) in Bulgaria and Aid flow (current US$) in Macedonia?
Your answer should be very brief. -1.08e+07. In the year 2003, what is the difference between the Aid flow (current US$) in Bulgaria and Aid flow (current US$) in Somalia?
Offer a terse response. -3.92e+07. In the year 2003, what is the difference between the Aid flow (current US$) of Macedonia and Aid flow (current US$) of Somalia?
Keep it short and to the point. -2.85e+07. In the year 2004, what is the difference between the Aid flow (current US$) of Bangladesh and Aid flow (current US$) of Bulgaria?
Provide a succinct answer. 2.28e+07. In the year 2004, what is the difference between the Aid flow (current US$) in Bangladesh and Aid flow (current US$) in Macedonia?
Your answer should be compact. 1.13e+07. In the year 2004, what is the difference between the Aid flow (current US$) of Bangladesh and Aid flow (current US$) of Somalia?
Provide a short and direct response. -9.75e+06. In the year 2004, what is the difference between the Aid flow (current US$) in Bulgaria and Aid flow (current US$) in Macedonia?
Your answer should be compact. -1.14e+07. In the year 2004, what is the difference between the Aid flow (current US$) of Bulgaria and Aid flow (current US$) of Somalia?
Keep it short and to the point. -3.25e+07. In the year 2004, what is the difference between the Aid flow (current US$) of Macedonia and Aid flow (current US$) of Somalia?
Keep it short and to the point. -2.11e+07. What is the ratio of the Aid flow (current US$) of Bangladesh in 1994 to that in 1997?
Keep it short and to the point. 1.13. What is the ratio of the Aid flow (current US$) in Macedonia in 1994 to that in 1997?
Provide a short and direct response. 18. What is the ratio of the Aid flow (current US$) in Somalia in 1994 to that in 1997?
Provide a short and direct response. 0.66. What is the ratio of the Aid flow (current US$) in Bangladesh in 1994 to that in 1998?
Provide a succinct answer. 1.23. What is the ratio of the Aid flow (current US$) of Somalia in 1994 to that in 1998?
Your response must be concise. 0.78. What is the ratio of the Aid flow (current US$) in Bangladesh in 1994 to that in 2000?
Your answer should be very brief. 2. What is the ratio of the Aid flow (current US$) in Bulgaria in 1994 to that in 2000?
Provide a succinct answer. 1. What is the ratio of the Aid flow (current US$) of Macedonia in 1994 to that in 2000?
Your response must be concise. 0.19. What is the ratio of the Aid flow (current US$) in Somalia in 1994 to that in 2000?
Provide a succinct answer. 0.32. What is the ratio of the Aid flow (current US$) in Bangladesh in 1994 to that in 2001?
Provide a short and direct response. 1.78. What is the ratio of the Aid flow (current US$) of Bulgaria in 1994 to that in 2001?
Provide a short and direct response. 0.14. What is the ratio of the Aid flow (current US$) in Macedonia in 1994 to that in 2001?
Give a very brief answer. 0.03. What is the ratio of the Aid flow (current US$) of Somalia in 1994 to that in 2001?
Offer a terse response. 0.51. What is the ratio of the Aid flow (current US$) in Bangladesh in 1994 to that in 2002?
Make the answer very short. 2.21. What is the ratio of the Aid flow (current US$) of Bulgaria in 1994 to that in 2002?
Your answer should be compact. 0.02. What is the ratio of the Aid flow (current US$) of Macedonia in 1994 to that in 2002?
Ensure brevity in your answer.  0.02. What is the ratio of the Aid flow (current US$) in Somalia in 1994 to that in 2002?
Your answer should be very brief. 0.25. What is the ratio of the Aid flow (current US$) of Bangladesh in 1994 to that in 2003?
Ensure brevity in your answer.  3.02. What is the ratio of the Aid flow (current US$) of Bulgaria in 1994 to that in 2003?
Your response must be concise. 0.01. What is the ratio of the Aid flow (current US$) of Macedonia in 1994 to that in 2003?
Ensure brevity in your answer.  0.02. What is the ratio of the Aid flow (current US$) of Somalia in 1994 to that in 2003?
Provide a short and direct response. 0.16. What is the ratio of the Aid flow (current US$) in Bangladesh in 1994 to that in 2004?
Provide a succinct answer. 1.53. What is the ratio of the Aid flow (current US$) in Bulgaria in 1994 to that in 2004?
Provide a succinct answer. 0.01. What is the ratio of the Aid flow (current US$) in Macedonia in 1994 to that in 2004?
Ensure brevity in your answer.  0.01. What is the ratio of the Aid flow (current US$) in Somalia in 1994 to that in 2004?
Provide a short and direct response. 0.19. What is the ratio of the Aid flow (current US$) in Bangladesh in 1997 to that in 1998?
Ensure brevity in your answer.  1.08. What is the ratio of the Aid flow (current US$) in Bulgaria in 1997 to that in 1998?
Offer a terse response. 0.6. What is the ratio of the Aid flow (current US$) of Macedonia in 1997 to that in 1998?
Make the answer very short. 0.07. What is the ratio of the Aid flow (current US$) in Somalia in 1997 to that in 1998?
Make the answer very short. 1.18. What is the ratio of the Aid flow (current US$) in Bangladesh in 1997 to that in 2000?
Offer a very short reply. 1.76. What is the ratio of the Aid flow (current US$) in Macedonia in 1997 to that in 2000?
Provide a short and direct response. 0.01. What is the ratio of the Aid flow (current US$) of Somalia in 1997 to that in 2000?
Give a very brief answer. 0.48. What is the ratio of the Aid flow (current US$) in Bangladesh in 1997 to that in 2001?
Provide a succinct answer. 1.57. What is the ratio of the Aid flow (current US$) in Bulgaria in 1997 to that in 2001?
Keep it short and to the point. 0.43. What is the ratio of the Aid flow (current US$) in Macedonia in 1997 to that in 2001?
Your response must be concise. 0. What is the ratio of the Aid flow (current US$) of Somalia in 1997 to that in 2001?
Your answer should be compact. 0.78. What is the ratio of the Aid flow (current US$) in Bangladesh in 1997 to that in 2002?
Offer a very short reply. 1.95. What is the ratio of the Aid flow (current US$) of Bulgaria in 1997 to that in 2002?
Your response must be concise. 0.06. What is the ratio of the Aid flow (current US$) in Macedonia in 1997 to that in 2002?
Provide a succinct answer. 0. What is the ratio of the Aid flow (current US$) of Somalia in 1997 to that in 2002?
Keep it short and to the point. 0.38. What is the ratio of the Aid flow (current US$) in Bangladesh in 1997 to that in 2003?
Offer a very short reply. 2.66. What is the ratio of the Aid flow (current US$) in Bulgaria in 1997 to that in 2003?
Keep it short and to the point. 0.04. What is the ratio of the Aid flow (current US$) of Macedonia in 1997 to that in 2003?
Ensure brevity in your answer.  0. What is the ratio of the Aid flow (current US$) of Somalia in 1997 to that in 2003?
Offer a terse response. 0.24. What is the ratio of the Aid flow (current US$) of Bangladesh in 1997 to that in 2004?
Offer a very short reply. 1.35. What is the ratio of the Aid flow (current US$) in Bulgaria in 1997 to that in 2004?
Offer a very short reply. 0.03. What is the ratio of the Aid flow (current US$) in Macedonia in 1997 to that in 2004?
Your response must be concise. 0. What is the ratio of the Aid flow (current US$) of Somalia in 1997 to that in 2004?
Ensure brevity in your answer.  0.28. What is the ratio of the Aid flow (current US$) in Bangladesh in 1998 to that in 2000?
Give a very brief answer. 1.63. What is the ratio of the Aid flow (current US$) in Bulgaria in 1998 to that in 2000?
Keep it short and to the point. 5. What is the ratio of the Aid flow (current US$) of Macedonia in 1998 to that in 2000?
Make the answer very short. 0.16. What is the ratio of the Aid flow (current US$) in Somalia in 1998 to that in 2000?
Give a very brief answer. 0.41. What is the ratio of the Aid flow (current US$) in Bangladesh in 1998 to that in 2001?
Provide a short and direct response. 1.45. What is the ratio of the Aid flow (current US$) of Bulgaria in 1998 to that in 2001?
Your answer should be compact. 0.71. What is the ratio of the Aid flow (current US$) in Macedonia in 1998 to that in 2001?
Your response must be concise. 0.02. What is the ratio of the Aid flow (current US$) in Somalia in 1998 to that in 2001?
Provide a succinct answer. 0.66. What is the ratio of the Aid flow (current US$) in Bangladesh in 1998 to that in 2002?
Your answer should be very brief. 1.8. What is the ratio of the Aid flow (current US$) of Bulgaria in 1998 to that in 2002?
Your response must be concise. 0.09. What is the ratio of the Aid flow (current US$) of Macedonia in 1998 to that in 2002?
Your answer should be compact. 0.01. What is the ratio of the Aid flow (current US$) in Somalia in 1998 to that in 2002?
Give a very brief answer. 0.32. What is the ratio of the Aid flow (current US$) of Bangladesh in 1998 to that in 2003?
Offer a very short reply. 2.46. What is the ratio of the Aid flow (current US$) in Bulgaria in 1998 to that in 2003?
Your answer should be very brief. 0.06. What is the ratio of the Aid flow (current US$) of Macedonia in 1998 to that in 2003?
Make the answer very short. 0.01. What is the ratio of the Aid flow (current US$) of Somalia in 1998 to that in 2003?
Provide a succinct answer. 0.2. What is the ratio of the Aid flow (current US$) in Bangladesh in 1998 to that in 2004?
Provide a succinct answer. 1.25. What is the ratio of the Aid flow (current US$) in Bulgaria in 1998 to that in 2004?
Your answer should be compact. 0.04. What is the ratio of the Aid flow (current US$) of Macedonia in 1998 to that in 2004?
Keep it short and to the point. 0.01. What is the ratio of the Aid flow (current US$) of Somalia in 1998 to that in 2004?
Offer a terse response. 0.24. What is the ratio of the Aid flow (current US$) in Bangladesh in 2000 to that in 2001?
Keep it short and to the point. 0.89. What is the ratio of the Aid flow (current US$) of Bulgaria in 2000 to that in 2001?
Provide a short and direct response. 0.14. What is the ratio of the Aid flow (current US$) in Macedonia in 2000 to that in 2001?
Provide a succinct answer. 0.15. What is the ratio of the Aid flow (current US$) in Somalia in 2000 to that in 2001?
Offer a very short reply. 1.63. What is the ratio of the Aid flow (current US$) in Bangladesh in 2000 to that in 2002?
Your answer should be very brief. 1.11. What is the ratio of the Aid flow (current US$) of Bulgaria in 2000 to that in 2002?
Provide a short and direct response. 0.02. What is the ratio of the Aid flow (current US$) of Macedonia in 2000 to that in 2002?
Your response must be concise. 0.08. What is the ratio of the Aid flow (current US$) of Somalia in 2000 to that in 2002?
Keep it short and to the point. 0.79. What is the ratio of the Aid flow (current US$) in Bangladesh in 2000 to that in 2003?
Your response must be concise. 1.51. What is the ratio of the Aid flow (current US$) of Bulgaria in 2000 to that in 2003?
Make the answer very short. 0.01. What is the ratio of the Aid flow (current US$) of Macedonia in 2000 to that in 2003?
Provide a succinct answer. 0.08. What is the ratio of the Aid flow (current US$) of Somalia in 2000 to that in 2003?
Offer a very short reply. 0.5. What is the ratio of the Aid flow (current US$) of Bangladesh in 2000 to that in 2004?
Offer a terse response. 0.77. What is the ratio of the Aid flow (current US$) of Bulgaria in 2000 to that in 2004?
Your answer should be very brief. 0.01. What is the ratio of the Aid flow (current US$) in Macedonia in 2000 to that in 2004?
Give a very brief answer. 0.08. What is the ratio of the Aid flow (current US$) in Somalia in 2000 to that in 2004?
Offer a very short reply. 0.6. What is the ratio of the Aid flow (current US$) in Bangladesh in 2001 to that in 2002?
Ensure brevity in your answer.  1.24. What is the ratio of the Aid flow (current US$) of Bulgaria in 2001 to that in 2002?
Your answer should be compact. 0.13. What is the ratio of the Aid flow (current US$) in Macedonia in 2001 to that in 2002?
Your answer should be very brief. 0.54. What is the ratio of the Aid flow (current US$) of Somalia in 2001 to that in 2002?
Your response must be concise. 0.49. What is the ratio of the Aid flow (current US$) of Bangladesh in 2001 to that in 2003?
Your answer should be compact. 1.69. What is the ratio of the Aid flow (current US$) in Bulgaria in 2001 to that in 2003?
Make the answer very short. 0.09. What is the ratio of the Aid flow (current US$) in Macedonia in 2001 to that in 2003?
Keep it short and to the point. 0.55. What is the ratio of the Aid flow (current US$) of Somalia in 2001 to that in 2003?
Offer a very short reply. 0.31. What is the ratio of the Aid flow (current US$) in Bangladesh in 2001 to that in 2004?
Provide a short and direct response. 0.86. What is the ratio of the Aid flow (current US$) in Bulgaria in 2001 to that in 2004?
Offer a very short reply. 0.06. What is the ratio of the Aid flow (current US$) in Macedonia in 2001 to that in 2004?
Keep it short and to the point. 0.5. What is the ratio of the Aid flow (current US$) in Somalia in 2001 to that in 2004?
Provide a succinct answer. 0.37. What is the ratio of the Aid flow (current US$) of Bangladesh in 2002 to that in 2003?
Your response must be concise. 1.37. What is the ratio of the Aid flow (current US$) in Bulgaria in 2002 to that in 2003?
Make the answer very short. 0.69. What is the ratio of the Aid flow (current US$) in Macedonia in 2002 to that in 2003?
Make the answer very short. 1.01. What is the ratio of the Aid flow (current US$) of Somalia in 2002 to that in 2003?
Ensure brevity in your answer.  0.64. What is the ratio of the Aid flow (current US$) in Bangladesh in 2002 to that in 2004?
Your answer should be very brief. 0.69. What is the ratio of the Aid flow (current US$) in Bulgaria in 2002 to that in 2004?
Your answer should be compact. 0.46. What is the ratio of the Aid flow (current US$) in Macedonia in 2002 to that in 2004?
Ensure brevity in your answer.  0.93. What is the ratio of the Aid flow (current US$) of Somalia in 2002 to that in 2004?
Your answer should be compact. 0.76. What is the ratio of the Aid flow (current US$) of Bangladesh in 2003 to that in 2004?
Provide a short and direct response. 0.51. What is the ratio of the Aid flow (current US$) in Bulgaria in 2003 to that in 2004?
Provide a short and direct response. 0.66. What is the ratio of the Aid flow (current US$) of Macedonia in 2003 to that in 2004?
Ensure brevity in your answer.  0.92. What is the ratio of the Aid flow (current US$) of Somalia in 2003 to that in 2004?
Give a very brief answer. 1.19. What is the difference between the highest and the second highest Aid flow (current US$) in Bangladesh?
Your answer should be compact. 4.36e+06. What is the difference between the highest and the second highest Aid flow (current US$) of Bulgaria?
Offer a very short reply. 3.90e+05. What is the difference between the highest and the second highest Aid flow (current US$) of Macedonia?
Keep it short and to the point. 9.40e+05. What is the difference between the highest and the second highest Aid flow (current US$) of Somalia?
Your answer should be very brief. 6.33e+06. What is the difference between the highest and the lowest Aid flow (current US$) in Bangladesh?
Your answer should be very brief. 2.46e+07. What is the difference between the highest and the lowest Aid flow (current US$) of Bulgaria?
Give a very brief answer. 1.15e+06. What is the difference between the highest and the lowest Aid flow (current US$) of Macedonia?
Keep it short and to the point. 1.26e+07. What is the difference between the highest and the lowest Aid flow (current US$) in Somalia?
Ensure brevity in your answer.  3.37e+07. 